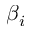Convert formula to latex. <formula><loc_0><loc_0><loc_500><loc_500>\beta _ { i }</formula> 